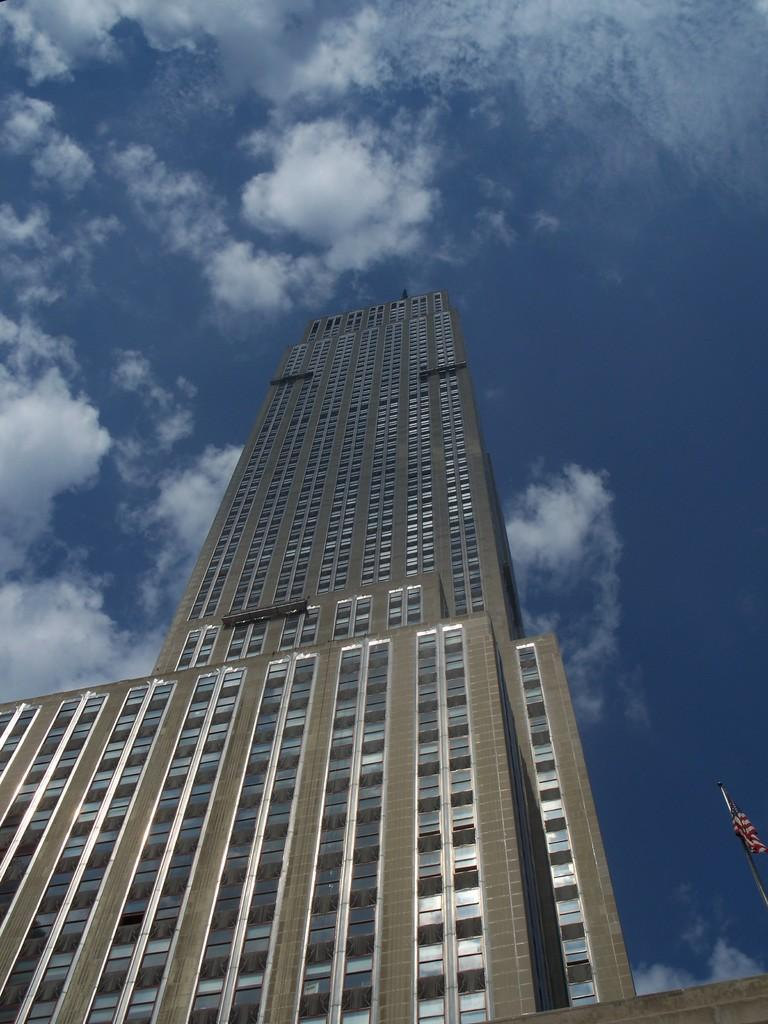What structure is the main subject of the image? There is a building in the image. What can be seen on the right side of the image? There is a pole with a flag on the right side of the image. What is visible in the background of the image? The sky is visible in the background of the image. What can be observed in the sky? Clouds are present in the sky. What type of horn can be heard in the image? There is no horn present in the image, and therefore no sound can be heard. 